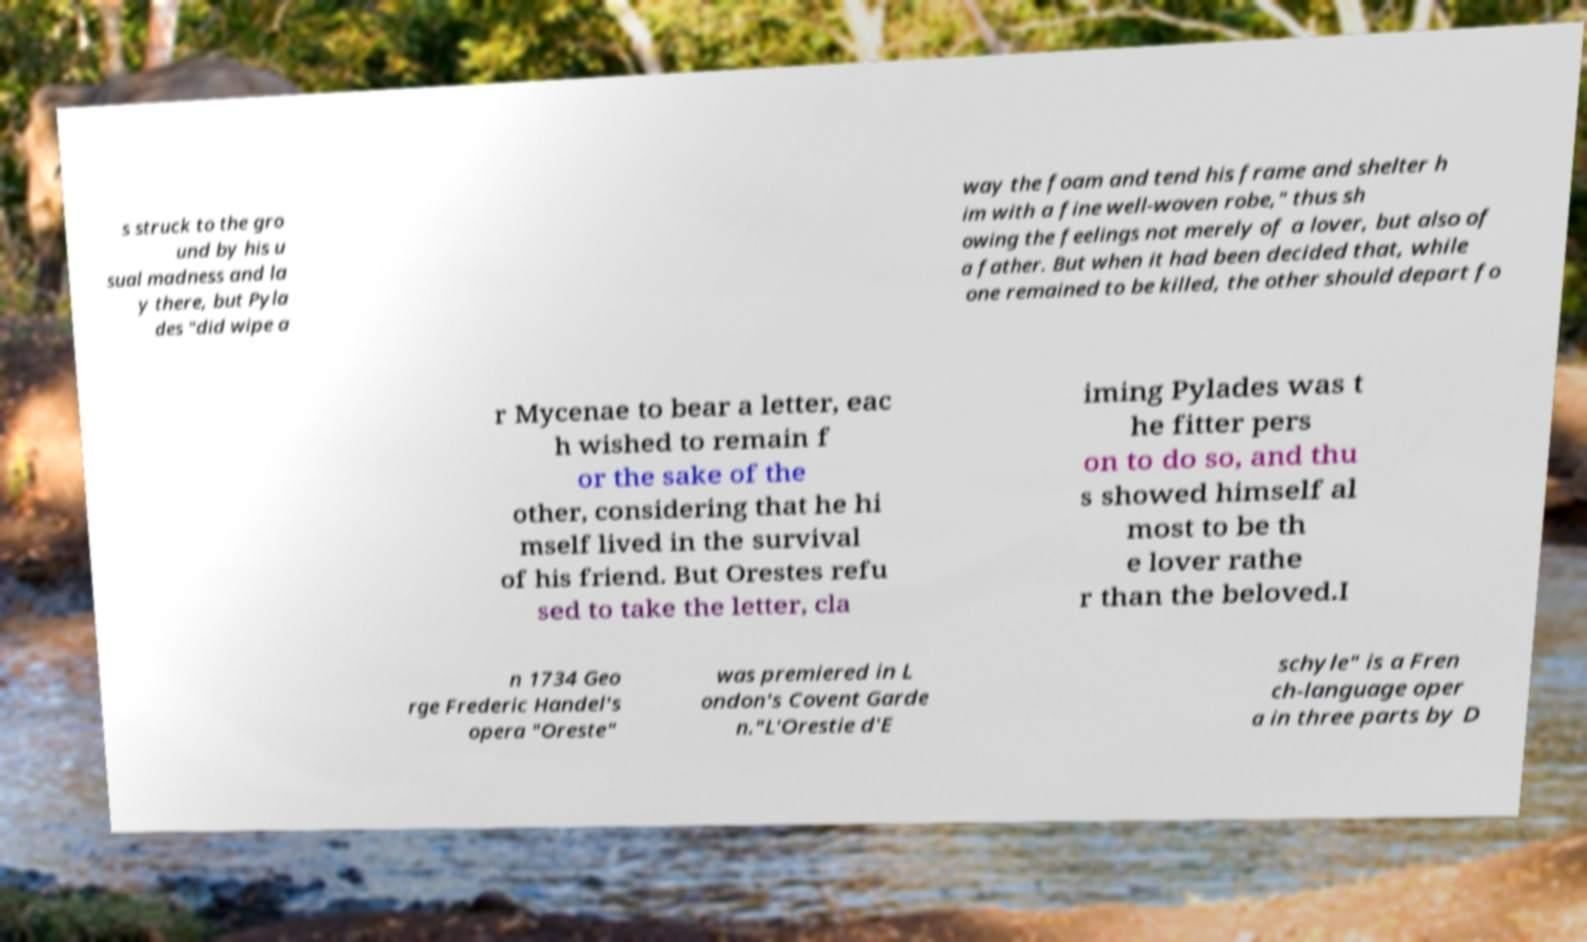For documentation purposes, I need the text within this image transcribed. Could you provide that? s struck to the gro und by his u sual madness and la y there, but Pyla des "did wipe a way the foam and tend his frame and shelter h im with a fine well-woven robe," thus sh owing the feelings not merely of a lover, but also of a father. But when it had been decided that, while one remained to be killed, the other should depart fo r Mycenae to bear a letter, eac h wished to remain f or the sake of the other, considering that he hi mself lived in the survival of his friend. But Orestes refu sed to take the letter, cla iming Pylades was t he fitter pers on to do so, and thu s showed himself al most to be th e lover rathe r than the beloved.I n 1734 Geo rge Frederic Handel's opera "Oreste" was premiered in L ondon's Covent Garde n."L'Orestie d'E schyle" is a Fren ch-language oper a in three parts by D 